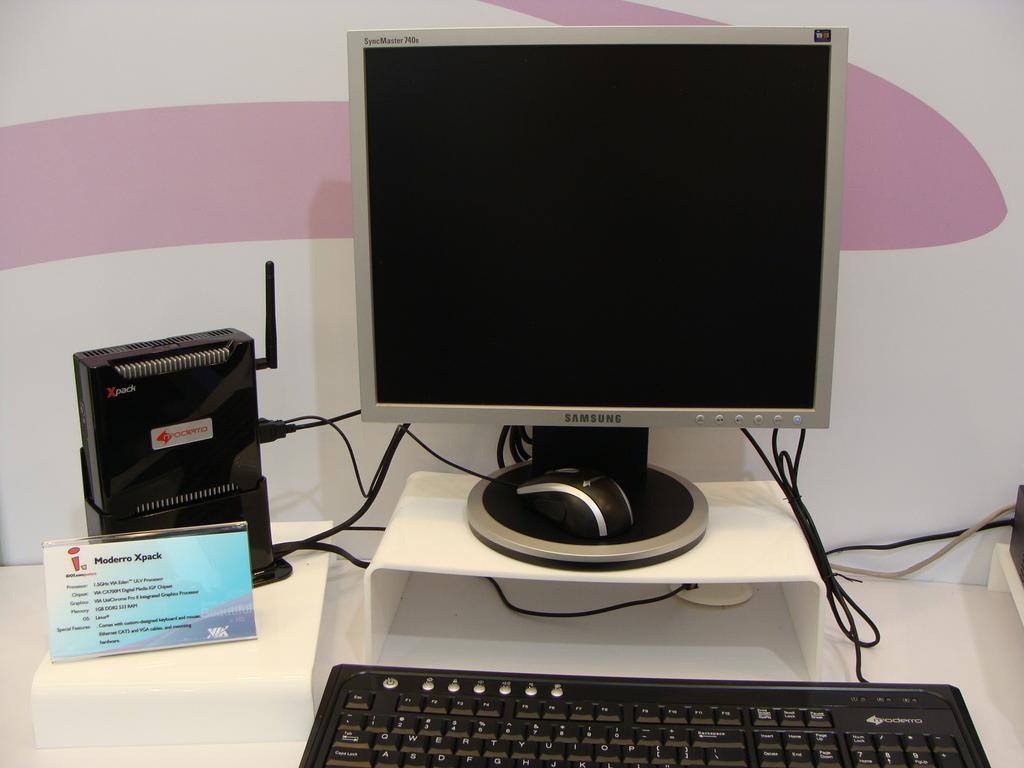Could you give a brief overview of what you see in this image? In this picture I can see personal computer. I can see electronic devices. I can see the wires. 